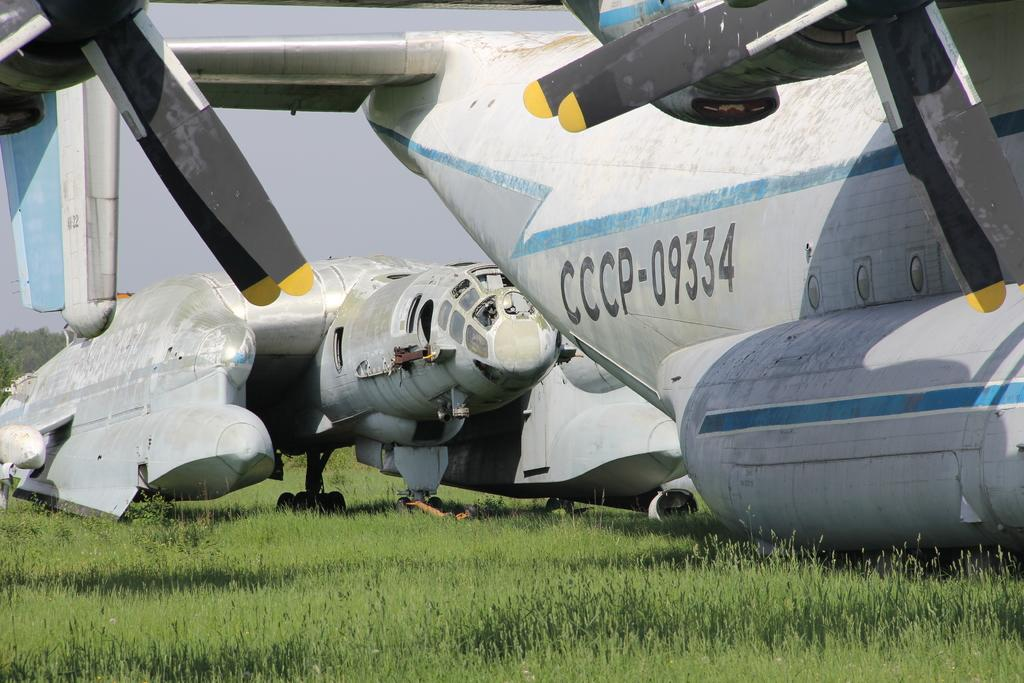<image>
Describe the image concisely. A jet with the number CCP-09334 on it sits in a field. 